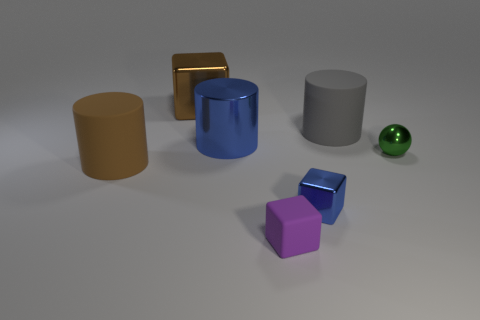What number of other large rubber objects are the same shape as the gray thing?
Your answer should be very brief. 1. What is the material of the blue cylinder?
Offer a very short reply. Metal. Are there the same number of big rubber cylinders to the left of the tiny rubber thing and yellow things?
Your answer should be very brief. No. The blue shiny object that is the same size as the purple block is what shape?
Your response must be concise. Cube. There is a rubber thing behind the brown matte cylinder; is there a small rubber block behind it?
Make the answer very short. No. How many tiny objects are yellow metallic cylinders or cylinders?
Provide a succinct answer. 0. Are there any red things of the same size as the gray thing?
Provide a short and direct response. No. How many rubber things are large brown objects or purple objects?
Keep it short and to the point. 2. There is a rubber thing that is the same color as the big block; what shape is it?
Ensure brevity in your answer.  Cylinder. How many brown metal objects are there?
Make the answer very short. 1. 